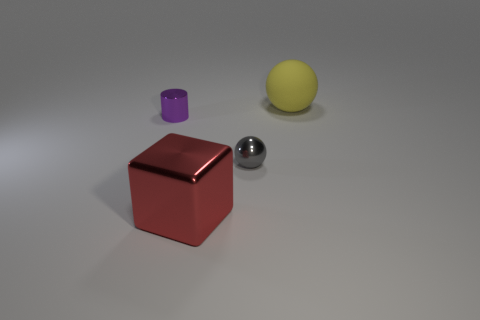What is the shape of the large thing that is the same material as the small sphere?
Your answer should be compact. Cube. There is a tiny purple thing; is its shape the same as the big object that is behind the small gray object?
Give a very brief answer. No. What is the tiny object that is on the right side of the object that is on the left side of the cube made of?
Your answer should be compact. Metal. What number of other things are there of the same shape as the gray object?
Your answer should be very brief. 1. Does the small object in front of the metal cylinder have the same shape as the metallic object that is on the left side of the large cube?
Make the answer very short. No. Is there anything else that is made of the same material as the yellow sphere?
Ensure brevity in your answer.  No. What is the large cube made of?
Make the answer very short. Metal. There is a tiny thing right of the tiny purple metallic thing; what material is it?
Your response must be concise. Metal. Is there anything else of the same color as the rubber object?
Provide a succinct answer. No. There is a sphere that is made of the same material as the red block; what is its size?
Offer a very short reply. Small. 